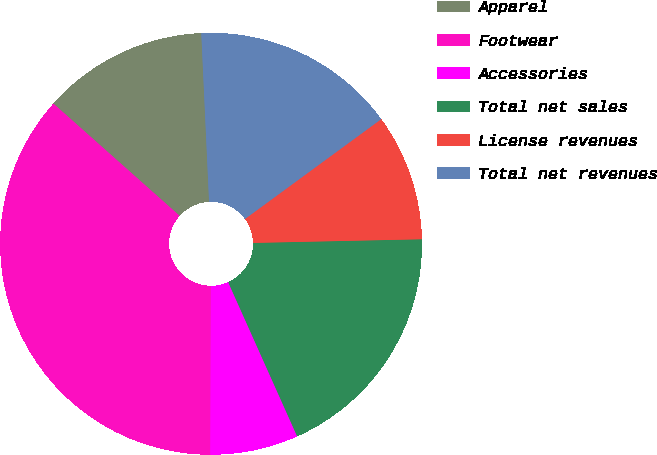Convert chart. <chart><loc_0><loc_0><loc_500><loc_500><pie_chart><fcel>Apparel<fcel>Footwear<fcel>Accessories<fcel>Total net sales<fcel>License revenues<fcel>Total net revenues<nl><fcel>12.7%<fcel>36.51%<fcel>6.75%<fcel>18.65%<fcel>9.72%<fcel>15.67%<nl></chart> 